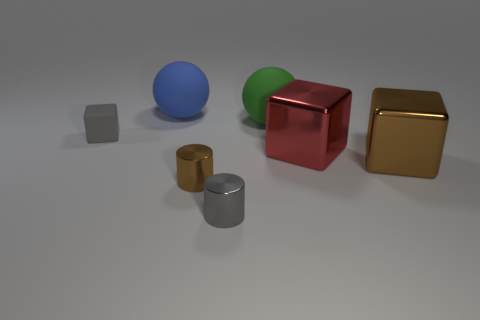There is a gray thing that is to the right of the gray matte thing that is behind the big brown block; what size is it?
Keep it short and to the point. Small. Is the number of gray rubber cubes that are on the right side of the big blue rubber object the same as the number of green balls that are to the right of the big red metal object?
Your response must be concise. Yes. There is a big shiny block that is on the right side of the big red shiny block; are there any brown metallic cylinders to the right of it?
Your answer should be compact. No. How many tiny objects are behind the gray object to the left of the small gray thing in front of the brown shiny cube?
Make the answer very short. 0. Are there fewer purple shiny spheres than rubber spheres?
Offer a terse response. Yes. There is a large metal thing that is behind the big brown metal object; is its shape the same as the tiny gray thing that is in front of the matte block?
Give a very brief answer. No. What is the color of the small matte object?
Offer a terse response. Gray. What number of metal objects are either red cubes or cylinders?
Provide a succinct answer. 3. The other rubber object that is the same shape as the red thing is what color?
Offer a terse response. Gray. Is there a big matte ball?
Your answer should be very brief. Yes. 